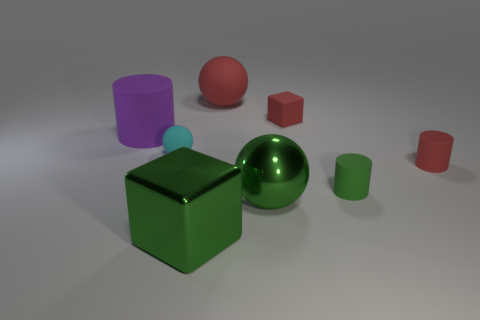Add 2 large rubber spheres. How many objects exist? 10 Subtract all balls. How many objects are left? 5 Subtract all tiny blue shiny cylinders. Subtract all large metallic things. How many objects are left? 6 Add 7 big purple things. How many big purple things are left? 8 Add 2 big purple metal cylinders. How many big purple metal cylinders exist? 2 Subtract 0 cyan cylinders. How many objects are left? 8 